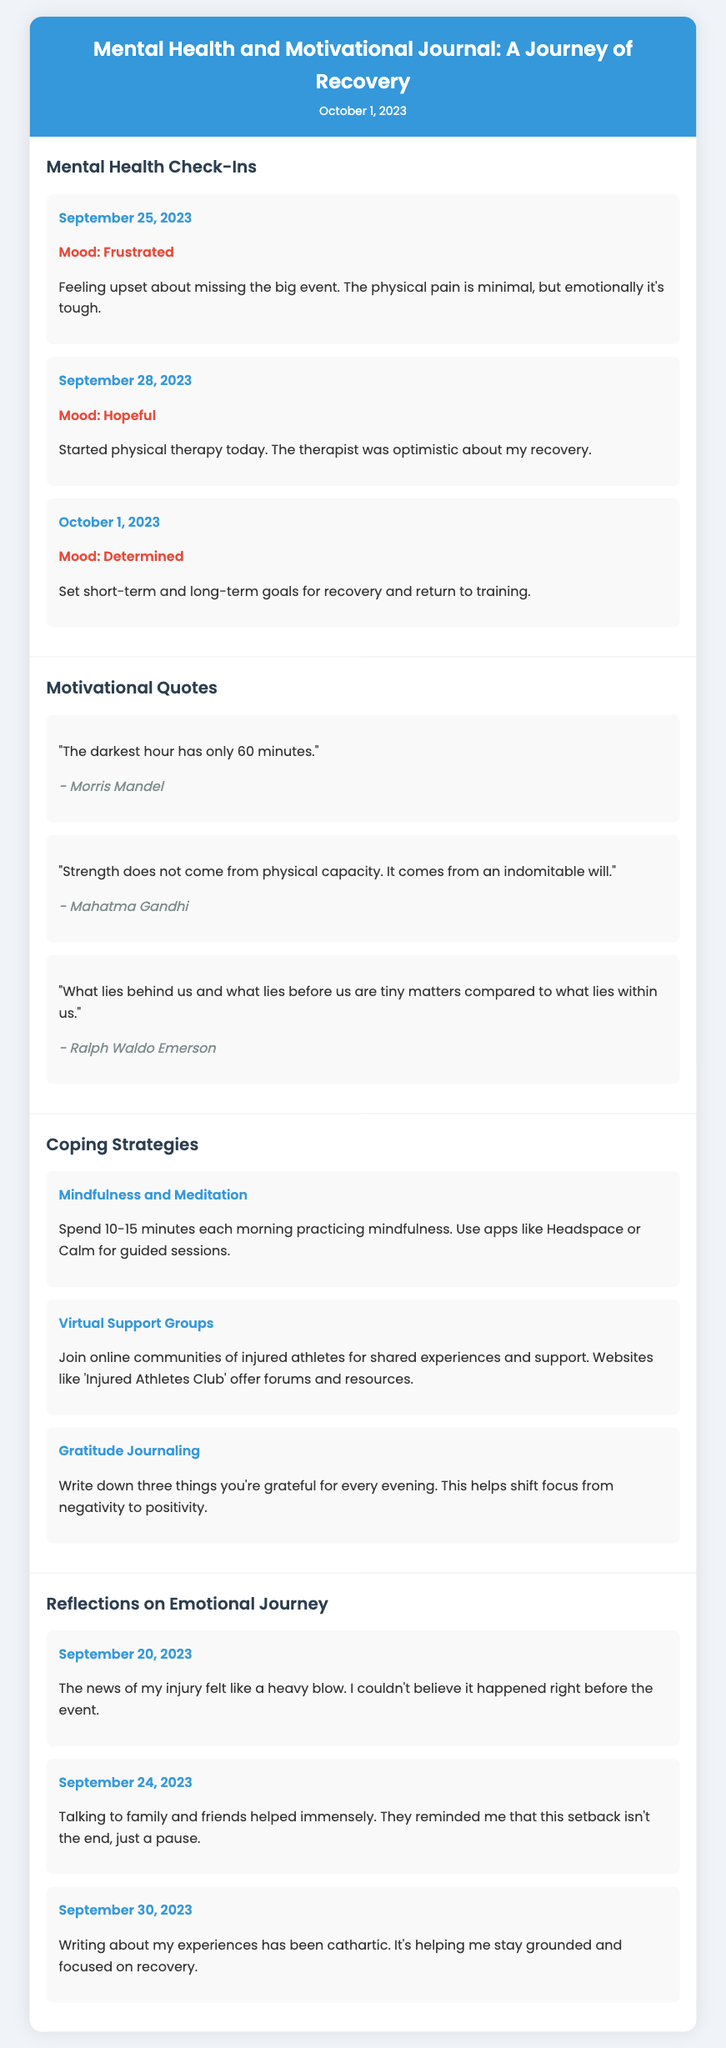What is the mood recorded on September 25, 2023? The mood recorded on that date is listed under the log entry, which states "Mood: Frustrated."
Answer: Frustrated What is the date of the last log entry? The last log entry is dated October 1, 2023, mentioned in the section for mental health check-ins.
Answer: October 1, 2023 How many motivational quotes are provided in the journal? The section for motivational quotes lists three different quotes, each presented in its own block.
Answer: Three What coping strategy involves writing down things you're grateful for? In the coping strategies section, there is a strategy titled "Gratitude Journaling" which describes this practice.
Answer: Gratitude Journaling What emotional reflection talks about seeking support from family and friends? This reflection is dated September 24, 2023, and describes the positive impact of talking to loved ones.
Answer: September 24, 2023 What was the author's mood on October 1, 2023? The author's mood entry for that date indicates "Mood: Determined," reflecting a positive outlook.
Answer: Determined Which motivational quote is attributed to Mahatma Gandhi? The quote by Mahatma Gandhi is listed as "Strength does not come from physical capacity. It comes from an indomitable will."
Answer: Strength does not come from physical capacity. It comes from an indomitable will What date did the author start physical therapy? The entry dated September 28, 2023, mentions the start of physical therapy, indicating a focus during this period.
Answer: September 28, 2023 What is the first strategy mentioned for coping? The first coping strategy listed is "Mindfulness and Meditation," which outlines a practice for mental health.
Answer: Mindfulness and Meditation 